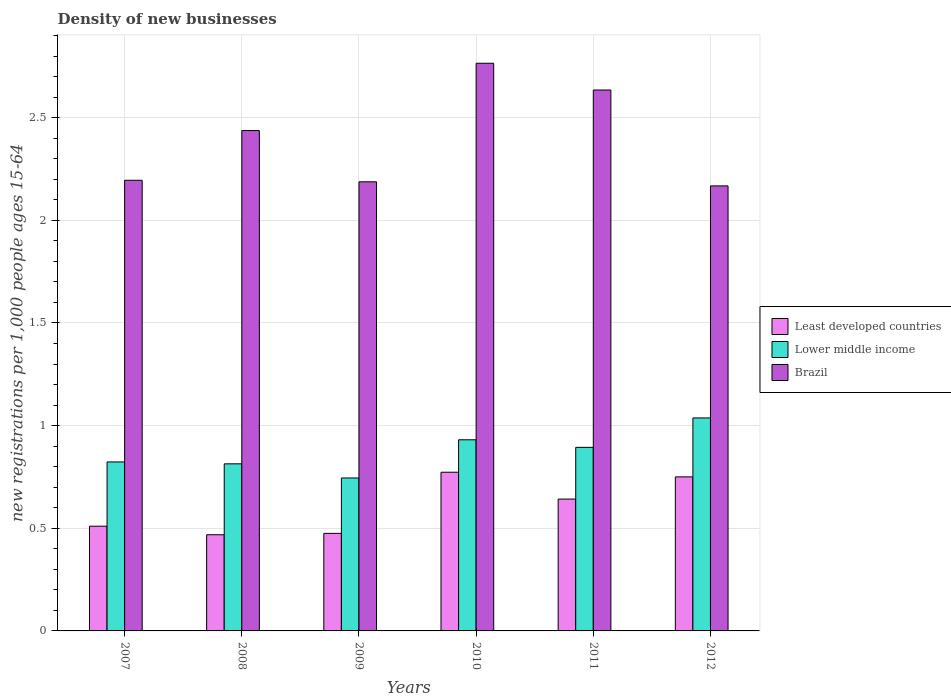In how many cases, is the number of bars for a given year not equal to the number of legend labels?
Make the answer very short. 0. What is the number of new registrations in Lower middle income in 2008?
Offer a terse response. 0.81. Across all years, what is the maximum number of new registrations in Least developed countries?
Make the answer very short. 0.77. Across all years, what is the minimum number of new registrations in Brazil?
Provide a succinct answer. 2.17. In which year was the number of new registrations in Lower middle income maximum?
Offer a terse response. 2012. In which year was the number of new registrations in Lower middle income minimum?
Make the answer very short. 2009. What is the total number of new registrations in Least developed countries in the graph?
Provide a short and direct response. 3.62. What is the difference between the number of new registrations in Lower middle income in 2008 and that in 2010?
Your answer should be compact. -0.12. What is the difference between the number of new registrations in Brazil in 2008 and the number of new registrations in Lower middle income in 2009?
Your answer should be compact. 1.69. What is the average number of new registrations in Brazil per year?
Give a very brief answer. 2.4. In the year 2008, what is the difference between the number of new registrations in Brazil and number of new registrations in Lower middle income?
Make the answer very short. 1.62. In how many years, is the number of new registrations in Least developed countries greater than 1?
Offer a terse response. 0. What is the ratio of the number of new registrations in Lower middle income in 2007 to that in 2008?
Your answer should be very brief. 1.01. Is the difference between the number of new registrations in Brazil in 2010 and 2012 greater than the difference between the number of new registrations in Lower middle income in 2010 and 2012?
Keep it short and to the point. Yes. What is the difference between the highest and the second highest number of new registrations in Lower middle income?
Ensure brevity in your answer.  0.11. What is the difference between the highest and the lowest number of new registrations in Brazil?
Keep it short and to the point. 0.6. What does the 1st bar from the right in 2009 represents?
Offer a terse response. Brazil. How many years are there in the graph?
Your answer should be very brief. 6. Are the values on the major ticks of Y-axis written in scientific E-notation?
Your answer should be very brief. No. Does the graph contain grids?
Your answer should be very brief. Yes. Where does the legend appear in the graph?
Offer a very short reply. Center right. What is the title of the graph?
Your answer should be compact. Density of new businesses. What is the label or title of the X-axis?
Provide a short and direct response. Years. What is the label or title of the Y-axis?
Ensure brevity in your answer.  New registrations per 1,0 people ages 15-64. What is the new registrations per 1,000 people ages 15-64 in Least developed countries in 2007?
Keep it short and to the point. 0.51. What is the new registrations per 1,000 people ages 15-64 of Lower middle income in 2007?
Keep it short and to the point. 0.82. What is the new registrations per 1,000 people ages 15-64 in Brazil in 2007?
Your answer should be very brief. 2.19. What is the new registrations per 1,000 people ages 15-64 in Least developed countries in 2008?
Make the answer very short. 0.47. What is the new registrations per 1,000 people ages 15-64 in Lower middle income in 2008?
Make the answer very short. 0.81. What is the new registrations per 1,000 people ages 15-64 of Brazil in 2008?
Offer a very short reply. 2.44. What is the new registrations per 1,000 people ages 15-64 in Least developed countries in 2009?
Your answer should be very brief. 0.48. What is the new registrations per 1,000 people ages 15-64 in Lower middle income in 2009?
Your answer should be very brief. 0.74. What is the new registrations per 1,000 people ages 15-64 of Brazil in 2009?
Provide a short and direct response. 2.19. What is the new registrations per 1,000 people ages 15-64 of Least developed countries in 2010?
Keep it short and to the point. 0.77. What is the new registrations per 1,000 people ages 15-64 of Lower middle income in 2010?
Your answer should be very brief. 0.93. What is the new registrations per 1,000 people ages 15-64 in Brazil in 2010?
Provide a short and direct response. 2.76. What is the new registrations per 1,000 people ages 15-64 in Least developed countries in 2011?
Your answer should be compact. 0.64. What is the new registrations per 1,000 people ages 15-64 in Lower middle income in 2011?
Ensure brevity in your answer.  0.89. What is the new registrations per 1,000 people ages 15-64 in Brazil in 2011?
Make the answer very short. 2.63. What is the new registrations per 1,000 people ages 15-64 of Least developed countries in 2012?
Offer a terse response. 0.75. What is the new registrations per 1,000 people ages 15-64 of Lower middle income in 2012?
Give a very brief answer. 1.04. What is the new registrations per 1,000 people ages 15-64 of Brazil in 2012?
Your answer should be very brief. 2.17. Across all years, what is the maximum new registrations per 1,000 people ages 15-64 of Least developed countries?
Provide a short and direct response. 0.77. Across all years, what is the maximum new registrations per 1,000 people ages 15-64 of Lower middle income?
Keep it short and to the point. 1.04. Across all years, what is the maximum new registrations per 1,000 people ages 15-64 in Brazil?
Give a very brief answer. 2.76. Across all years, what is the minimum new registrations per 1,000 people ages 15-64 of Least developed countries?
Ensure brevity in your answer.  0.47. Across all years, what is the minimum new registrations per 1,000 people ages 15-64 in Lower middle income?
Your answer should be very brief. 0.74. Across all years, what is the minimum new registrations per 1,000 people ages 15-64 in Brazil?
Your answer should be very brief. 2.17. What is the total new registrations per 1,000 people ages 15-64 of Least developed countries in the graph?
Your answer should be very brief. 3.62. What is the total new registrations per 1,000 people ages 15-64 of Lower middle income in the graph?
Make the answer very short. 5.24. What is the total new registrations per 1,000 people ages 15-64 of Brazil in the graph?
Make the answer very short. 14.39. What is the difference between the new registrations per 1,000 people ages 15-64 in Least developed countries in 2007 and that in 2008?
Give a very brief answer. 0.04. What is the difference between the new registrations per 1,000 people ages 15-64 of Lower middle income in 2007 and that in 2008?
Give a very brief answer. 0.01. What is the difference between the new registrations per 1,000 people ages 15-64 of Brazil in 2007 and that in 2008?
Offer a terse response. -0.24. What is the difference between the new registrations per 1,000 people ages 15-64 of Least developed countries in 2007 and that in 2009?
Offer a very short reply. 0.03. What is the difference between the new registrations per 1,000 people ages 15-64 in Lower middle income in 2007 and that in 2009?
Your answer should be very brief. 0.08. What is the difference between the new registrations per 1,000 people ages 15-64 of Brazil in 2007 and that in 2009?
Provide a succinct answer. 0.01. What is the difference between the new registrations per 1,000 people ages 15-64 of Least developed countries in 2007 and that in 2010?
Your answer should be very brief. -0.26. What is the difference between the new registrations per 1,000 people ages 15-64 of Lower middle income in 2007 and that in 2010?
Ensure brevity in your answer.  -0.11. What is the difference between the new registrations per 1,000 people ages 15-64 of Brazil in 2007 and that in 2010?
Make the answer very short. -0.57. What is the difference between the new registrations per 1,000 people ages 15-64 of Least developed countries in 2007 and that in 2011?
Make the answer very short. -0.13. What is the difference between the new registrations per 1,000 people ages 15-64 of Lower middle income in 2007 and that in 2011?
Keep it short and to the point. -0.07. What is the difference between the new registrations per 1,000 people ages 15-64 in Brazil in 2007 and that in 2011?
Keep it short and to the point. -0.44. What is the difference between the new registrations per 1,000 people ages 15-64 of Least developed countries in 2007 and that in 2012?
Your response must be concise. -0.24. What is the difference between the new registrations per 1,000 people ages 15-64 in Lower middle income in 2007 and that in 2012?
Make the answer very short. -0.21. What is the difference between the new registrations per 1,000 people ages 15-64 in Brazil in 2007 and that in 2012?
Your response must be concise. 0.03. What is the difference between the new registrations per 1,000 people ages 15-64 of Least developed countries in 2008 and that in 2009?
Offer a very short reply. -0.01. What is the difference between the new registrations per 1,000 people ages 15-64 of Lower middle income in 2008 and that in 2009?
Provide a short and direct response. 0.07. What is the difference between the new registrations per 1,000 people ages 15-64 of Brazil in 2008 and that in 2009?
Provide a short and direct response. 0.25. What is the difference between the new registrations per 1,000 people ages 15-64 in Least developed countries in 2008 and that in 2010?
Offer a terse response. -0.3. What is the difference between the new registrations per 1,000 people ages 15-64 of Lower middle income in 2008 and that in 2010?
Make the answer very short. -0.12. What is the difference between the new registrations per 1,000 people ages 15-64 in Brazil in 2008 and that in 2010?
Offer a very short reply. -0.33. What is the difference between the new registrations per 1,000 people ages 15-64 in Least developed countries in 2008 and that in 2011?
Your answer should be compact. -0.17. What is the difference between the new registrations per 1,000 people ages 15-64 of Lower middle income in 2008 and that in 2011?
Your answer should be compact. -0.08. What is the difference between the new registrations per 1,000 people ages 15-64 of Brazil in 2008 and that in 2011?
Make the answer very short. -0.2. What is the difference between the new registrations per 1,000 people ages 15-64 of Least developed countries in 2008 and that in 2012?
Offer a very short reply. -0.28. What is the difference between the new registrations per 1,000 people ages 15-64 of Lower middle income in 2008 and that in 2012?
Provide a short and direct response. -0.22. What is the difference between the new registrations per 1,000 people ages 15-64 in Brazil in 2008 and that in 2012?
Make the answer very short. 0.27. What is the difference between the new registrations per 1,000 people ages 15-64 in Least developed countries in 2009 and that in 2010?
Your answer should be compact. -0.3. What is the difference between the new registrations per 1,000 people ages 15-64 in Lower middle income in 2009 and that in 2010?
Offer a very short reply. -0.19. What is the difference between the new registrations per 1,000 people ages 15-64 of Brazil in 2009 and that in 2010?
Ensure brevity in your answer.  -0.58. What is the difference between the new registrations per 1,000 people ages 15-64 in Least developed countries in 2009 and that in 2011?
Provide a short and direct response. -0.17. What is the difference between the new registrations per 1,000 people ages 15-64 of Lower middle income in 2009 and that in 2011?
Provide a succinct answer. -0.15. What is the difference between the new registrations per 1,000 people ages 15-64 in Brazil in 2009 and that in 2011?
Make the answer very short. -0.45. What is the difference between the new registrations per 1,000 people ages 15-64 in Least developed countries in 2009 and that in 2012?
Your answer should be very brief. -0.28. What is the difference between the new registrations per 1,000 people ages 15-64 in Lower middle income in 2009 and that in 2012?
Offer a terse response. -0.29. What is the difference between the new registrations per 1,000 people ages 15-64 of Brazil in 2009 and that in 2012?
Offer a terse response. 0.02. What is the difference between the new registrations per 1,000 people ages 15-64 in Least developed countries in 2010 and that in 2011?
Give a very brief answer. 0.13. What is the difference between the new registrations per 1,000 people ages 15-64 in Lower middle income in 2010 and that in 2011?
Offer a terse response. 0.04. What is the difference between the new registrations per 1,000 people ages 15-64 in Brazil in 2010 and that in 2011?
Make the answer very short. 0.13. What is the difference between the new registrations per 1,000 people ages 15-64 of Least developed countries in 2010 and that in 2012?
Offer a terse response. 0.02. What is the difference between the new registrations per 1,000 people ages 15-64 in Lower middle income in 2010 and that in 2012?
Keep it short and to the point. -0.11. What is the difference between the new registrations per 1,000 people ages 15-64 in Brazil in 2010 and that in 2012?
Your response must be concise. 0.6. What is the difference between the new registrations per 1,000 people ages 15-64 in Least developed countries in 2011 and that in 2012?
Ensure brevity in your answer.  -0.11. What is the difference between the new registrations per 1,000 people ages 15-64 of Lower middle income in 2011 and that in 2012?
Your response must be concise. -0.14. What is the difference between the new registrations per 1,000 people ages 15-64 of Brazil in 2011 and that in 2012?
Offer a very short reply. 0.47. What is the difference between the new registrations per 1,000 people ages 15-64 of Least developed countries in 2007 and the new registrations per 1,000 people ages 15-64 of Lower middle income in 2008?
Your response must be concise. -0.3. What is the difference between the new registrations per 1,000 people ages 15-64 in Least developed countries in 2007 and the new registrations per 1,000 people ages 15-64 in Brazil in 2008?
Your answer should be compact. -1.93. What is the difference between the new registrations per 1,000 people ages 15-64 of Lower middle income in 2007 and the new registrations per 1,000 people ages 15-64 of Brazil in 2008?
Offer a very short reply. -1.61. What is the difference between the new registrations per 1,000 people ages 15-64 in Least developed countries in 2007 and the new registrations per 1,000 people ages 15-64 in Lower middle income in 2009?
Offer a terse response. -0.23. What is the difference between the new registrations per 1,000 people ages 15-64 of Least developed countries in 2007 and the new registrations per 1,000 people ages 15-64 of Brazil in 2009?
Your answer should be very brief. -1.68. What is the difference between the new registrations per 1,000 people ages 15-64 of Lower middle income in 2007 and the new registrations per 1,000 people ages 15-64 of Brazil in 2009?
Provide a short and direct response. -1.36. What is the difference between the new registrations per 1,000 people ages 15-64 in Least developed countries in 2007 and the new registrations per 1,000 people ages 15-64 in Lower middle income in 2010?
Your answer should be compact. -0.42. What is the difference between the new registrations per 1,000 people ages 15-64 in Least developed countries in 2007 and the new registrations per 1,000 people ages 15-64 in Brazil in 2010?
Provide a succinct answer. -2.25. What is the difference between the new registrations per 1,000 people ages 15-64 in Lower middle income in 2007 and the new registrations per 1,000 people ages 15-64 in Brazil in 2010?
Provide a succinct answer. -1.94. What is the difference between the new registrations per 1,000 people ages 15-64 of Least developed countries in 2007 and the new registrations per 1,000 people ages 15-64 of Lower middle income in 2011?
Offer a very short reply. -0.38. What is the difference between the new registrations per 1,000 people ages 15-64 of Least developed countries in 2007 and the new registrations per 1,000 people ages 15-64 of Brazil in 2011?
Your response must be concise. -2.12. What is the difference between the new registrations per 1,000 people ages 15-64 in Lower middle income in 2007 and the new registrations per 1,000 people ages 15-64 in Brazil in 2011?
Your response must be concise. -1.81. What is the difference between the new registrations per 1,000 people ages 15-64 in Least developed countries in 2007 and the new registrations per 1,000 people ages 15-64 in Lower middle income in 2012?
Your answer should be very brief. -0.53. What is the difference between the new registrations per 1,000 people ages 15-64 in Least developed countries in 2007 and the new registrations per 1,000 people ages 15-64 in Brazil in 2012?
Your response must be concise. -1.66. What is the difference between the new registrations per 1,000 people ages 15-64 in Lower middle income in 2007 and the new registrations per 1,000 people ages 15-64 in Brazil in 2012?
Your answer should be compact. -1.34. What is the difference between the new registrations per 1,000 people ages 15-64 of Least developed countries in 2008 and the new registrations per 1,000 people ages 15-64 of Lower middle income in 2009?
Give a very brief answer. -0.28. What is the difference between the new registrations per 1,000 people ages 15-64 in Least developed countries in 2008 and the new registrations per 1,000 people ages 15-64 in Brazil in 2009?
Make the answer very short. -1.72. What is the difference between the new registrations per 1,000 people ages 15-64 in Lower middle income in 2008 and the new registrations per 1,000 people ages 15-64 in Brazil in 2009?
Ensure brevity in your answer.  -1.37. What is the difference between the new registrations per 1,000 people ages 15-64 in Least developed countries in 2008 and the new registrations per 1,000 people ages 15-64 in Lower middle income in 2010?
Make the answer very short. -0.46. What is the difference between the new registrations per 1,000 people ages 15-64 in Least developed countries in 2008 and the new registrations per 1,000 people ages 15-64 in Brazil in 2010?
Ensure brevity in your answer.  -2.3. What is the difference between the new registrations per 1,000 people ages 15-64 in Lower middle income in 2008 and the new registrations per 1,000 people ages 15-64 in Brazil in 2010?
Make the answer very short. -1.95. What is the difference between the new registrations per 1,000 people ages 15-64 of Least developed countries in 2008 and the new registrations per 1,000 people ages 15-64 of Lower middle income in 2011?
Provide a short and direct response. -0.43. What is the difference between the new registrations per 1,000 people ages 15-64 in Least developed countries in 2008 and the new registrations per 1,000 people ages 15-64 in Brazil in 2011?
Your response must be concise. -2.17. What is the difference between the new registrations per 1,000 people ages 15-64 in Lower middle income in 2008 and the new registrations per 1,000 people ages 15-64 in Brazil in 2011?
Your answer should be compact. -1.82. What is the difference between the new registrations per 1,000 people ages 15-64 of Least developed countries in 2008 and the new registrations per 1,000 people ages 15-64 of Lower middle income in 2012?
Keep it short and to the point. -0.57. What is the difference between the new registrations per 1,000 people ages 15-64 of Least developed countries in 2008 and the new registrations per 1,000 people ages 15-64 of Brazil in 2012?
Provide a succinct answer. -1.7. What is the difference between the new registrations per 1,000 people ages 15-64 in Lower middle income in 2008 and the new registrations per 1,000 people ages 15-64 in Brazil in 2012?
Provide a short and direct response. -1.35. What is the difference between the new registrations per 1,000 people ages 15-64 of Least developed countries in 2009 and the new registrations per 1,000 people ages 15-64 of Lower middle income in 2010?
Offer a terse response. -0.46. What is the difference between the new registrations per 1,000 people ages 15-64 of Least developed countries in 2009 and the new registrations per 1,000 people ages 15-64 of Brazil in 2010?
Provide a short and direct response. -2.29. What is the difference between the new registrations per 1,000 people ages 15-64 of Lower middle income in 2009 and the new registrations per 1,000 people ages 15-64 of Brazil in 2010?
Make the answer very short. -2.02. What is the difference between the new registrations per 1,000 people ages 15-64 in Least developed countries in 2009 and the new registrations per 1,000 people ages 15-64 in Lower middle income in 2011?
Ensure brevity in your answer.  -0.42. What is the difference between the new registrations per 1,000 people ages 15-64 in Least developed countries in 2009 and the new registrations per 1,000 people ages 15-64 in Brazil in 2011?
Your answer should be very brief. -2.16. What is the difference between the new registrations per 1,000 people ages 15-64 in Lower middle income in 2009 and the new registrations per 1,000 people ages 15-64 in Brazil in 2011?
Your answer should be very brief. -1.89. What is the difference between the new registrations per 1,000 people ages 15-64 of Least developed countries in 2009 and the new registrations per 1,000 people ages 15-64 of Lower middle income in 2012?
Make the answer very short. -0.56. What is the difference between the new registrations per 1,000 people ages 15-64 of Least developed countries in 2009 and the new registrations per 1,000 people ages 15-64 of Brazil in 2012?
Ensure brevity in your answer.  -1.69. What is the difference between the new registrations per 1,000 people ages 15-64 in Lower middle income in 2009 and the new registrations per 1,000 people ages 15-64 in Brazil in 2012?
Keep it short and to the point. -1.42. What is the difference between the new registrations per 1,000 people ages 15-64 of Least developed countries in 2010 and the new registrations per 1,000 people ages 15-64 of Lower middle income in 2011?
Provide a short and direct response. -0.12. What is the difference between the new registrations per 1,000 people ages 15-64 of Least developed countries in 2010 and the new registrations per 1,000 people ages 15-64 of Brazil in 2011?
Give a very brief answer. -1.86. What is the difference between the new registrations per 1,000 people ages 15-64 in Lower middle income in 2010 and the new registrations per 1,000 people ages 15-64 in Brazil in 2011?
Ensure brevity in your answer.  -1.7. What is the difference between the new registrations per 1,000 people ages 15-64 of Least developed countries in 2010 and the new registrations per 1,000 people ages 15-64 of Lower middle income in 2012?
Make the answer very short. -0.26. What is the difference between the new registrations per 1,000 people ages 15-64 in Least developed countries in 2010 and the new registrations per 1,000 people ages 15-64 in Brazil in 2012?
Provide a short and direct response. -1.39. What is the difference between the new registrations per 1,000 people ages 15-64 in Lower middle income in 2010 and the new registrations per 1,000 people ages 15-64 in Brazil in 2012?
Provide a succinct answer. -1.24. What is the difference between the new registrations per 1,000 people ages 15-64 in Least developed countries in 2011 and the new registrations per 1,000 people ages 15-64 in Lower middle income in 2012?
Provide a succinct answer. -0.4. What is the difference between the new registrations per 1,000 people ages 15-64 of Least developed countries in 2011 and the new registrations per 1,000 people ages 15-64 of Brazil in 2012?
Your response must be concise. -1.53. What is the difference between the new registrations per 1,000 people ages 15-64 in Lower middle income in 2011 and the new registrations per 1,000 people ages 15-64 in Brazil in 2012?
Keep it short and to the point. -1.27. What is the average new registrations per 1,000 people ages 15-64 of Least developed countries per year?
Offer a very short reply. 0.6. What is the average new registrations per 1,000 people ages 15-64 of Lower middle income per year?
Offer a very short reply. 0.87. What is the average new registrations per 1,000 people ages 15-64 in Brazil per year?
Your response must be concise. 2.4. In the year 2007, what is the difference between the new registrations per 1,000 people ages 15-64 in Least developed countries and new registrations per 1,000 people ages 15-64 in Lower middle income?
Keep it short and to the point. -0.31. In the year 2007, what is the difference between the new registrations per 1,000 people ages 15-64 in Least developed countries and new registrations per 1,000 people ages 15-64 in Brazil?
Keep it short and to the point. -1.68. In the year 2007, what is the difference between the new registrations per 1,000 people ages 15-64 of Lower middle income and new registrations per 1,000 people ages 15-64 of Brazil?
Ensure brevity in your answer.  -1.37. In the year 2008, what is the difference between the new registrations per 1,000 people ages 15-64 in Least developed countries and new registrations per 1,000 people ages 15-64 in Lower middle income?
Ensure brevity in your answer.  -0.35. In the year 2008, what is the difference between the new registrations per 1,000 people ages 15-64 in Least developed countries and new registrations per 1,000 people ages 15-64 in Brazil?
Offer a terse response. -1.97. In the year 2008, what is the difference between the new registrations per 1,000 people ages 15-64 in Lower middle income and new registrations per 1,000 people ages 15-64 in Brazil?
Ensure brevity in your answer.  -1.62. In the year 2009, what is the difference between the new registrations per 1,000 people ages 15-64 in Least developed countries and new registrations per 1,000 people ages 15-64 in Lower middle income?
Make the answer very short. -0.27. In the year 2009, what is the difference between the new registrations per 1,000 people ages 15-64 of Least developed countries and new registrations per 1,000 people ages 15-64 of Brazil?
Offer a very short reply. -1.71. In the year 2009, what is the difference between the new registrations per 1,000 people ages 15-64 of Lower middle income and new registrations per 1,000 people ages 15-64 of Brazil?
Give a very brief answer. -1.44. In the year 2010, what is the difference between the new registrations per 1,000 people ages 15-64 in Least developed countries and new registrations per 1,000 people ages 15-64 in Lower middle income?
Your answer should be very brief. -0.16. In the year 2010, what is the difference between the new registrations per 1,000 people ages 15-64 of Least developed countries and new registrations per 1,000 people ages 15-64 of Brazil?
Offer a very short reply. -1.99. In the year 2010, what is the difference between the new registrations per 1,000 people ages 15-64 in Lower middle income and new registrations per 1,000 people ages 15-64 in Brazil?
Ensure brevity in your answer.  -1.83. In the year 2011, what is the difference between the new registrations per 1,000 people ages 15-64 in Least developed countries and new registrations per 1,000 people ages 15-64 in Lower middle income?
Offer a very short reply. -0.25. In the year 2011, what is the difference between the new registrations per 1,000 people ages 15-64 in Least developed countries and new registrations per 1,000 people ages 15-64 in Brazil?
Offer a very short reply. -1.99. In the year 2011, what is the difference between the new registrations per 1,000 people ages 15-64 of Lower middle income and new registrations per 1,000 people ages 15-64 of Brazil?
Offer a terse response. -1.74. In the year 2012, what is the difference between the new registrations per 1,000 people ages 15-64 in Least developed countries and new registrations per 1,000 people ages 15-64 in Lower middle income?
Ensure brevity in your answer.  -0.29. In the year 2012, what is the difference between the new registrations per 1,000 people ages 15-64 of Least developed countries and new registrations per 1,000 people ages 15-64 of Brazil?
Offer a terse response. -1.42. In the year 2012, what is the difference between the new registrations per 1,000 people ages 15-64 of Lower middle income and new registrations per 1,000 people ages 15-64 of Brazil?
Offer a terse response. -1.13. What is the ratio of the new registrations per 1,000 people ages 15-64 of Least developed countries in 2007 to that in 2008?
Provide a short and direct response. 1.09. What is the ratio of the new registrations per 1,000 people ages 15-64 in Lower middle income in 2007 to that in 2008?
Offer a very short reply. 1.01. What is the ratio of the new registrations per 1,000 people ages 15-64 in Brazil in 2007 to that in 2008?
Offer a very short reply. 0.9. What is the ratio of the new registrations per 1,000 people ages 15-64 in Least developed countries in 2007 to that in 2009?
Offer a very short reply. 1.07. What is the ratio of the new registrations per 1,000 people ages 15-64 in Lower middle income in 2007 to that in 2009?
Offer a very short reply. 1.1. What is the ratio of the new registrations per 1,000 people ages 15-64 of Least developed countries in 2007 to that in 2010?
Give a very brief answer. 0.66. What is the ratio of the new registrations per 1,000 people ages 15-64 of Lower middle income in 2007 to that in 2010?
Offer a terse response. 0.88. What is the ratio of the new registrations per 1,000 people ages 15-64 of Brazil in 2007 to that in 2010?
Provide a succinct answer. 0.79. What is the ratio of the new registrations per 1,000 people ages 15-64 of Least developed countries in 2007 to that in 2011?
Ensure brevity in your answer.  0.79. What is the ratio of the new registrations per 1,000 people ages 15-64 in Lower middle income in 2007 to that in 2011?
Your answer should be compact. 0.92. What is the ratio of the new registrations per 1,000 people ages 15-64 of Brazil in 2007 to that in 2011?
Provide a short and direct response. 0.83. What is the ratio of the new registrations per 1,000 people ages 15-64 in Least developed countries in 2007 to that in 2012?
Your answer should be compact. 0.68. What is the ratio of the new registrations per 1,000 people ages 15-64 of Lower middle income in 2007 to that in 2012?
Your answer should be compact. 0.79. What is the ratio of the new registrations per 1,000 people ages 15-64 of Brazil in 2007 to that in 2012?
Offer a very short reply. 1.01. What is the ratio of the new registrations per 1,000 people ages 15-64 in Least developed countries in 2008 to that in 2009?
Keep it short and to the point. 0.99. What is the ratio of the new registrations per 1,000 people ages 15-64 of Lower middle income in 2008 to that in 2009?
Offer a very short reply. 1.09. What is the ratio of the new registrations per 1,000 people ages 15-64 of Brazil in 2008 to that in 2009?
Offer a terse response. 1.11. What is the ratio of the new registrations per 1,000 people ages 15-64 of Least developed countries in 2008 to that in 2010?
Your answer should be compact. 0.61. What is the ratio of the new registrations per 1,000 people ages 15-64 in Lower middle income in 2008 to that in 2010?
Give a very brief answer. 0.87. What is the ratio of the new registrations per 1,000 people ages 15-64 in Brazil in 2008 to that in 2010?
Keep it short and to the point. 0.88. What is the ratio of the new registrations per 1,000 people ages 15-64 of Least developed countries in 2008 to that in 2011?
Ensure brevity in your answer.  0.73. What is the ratio of the new registrations per 1,000 people ages 15-64 in Lower middle income in 2008 to that in 2011?
Offer a terse response. 0.91. What is the ratio of the new registrations per 1,000 people ages 15-64 of Brazil in 2008 to that in 2011?
Your answer should be compact. 0.93. What is the ratio of the new registrations per 1,000 people ages 15-64 of Least developed countries in 2008 to that in 2012?
Offer a terse response. 0.62. What is the ratio of the new registrations per 1,000 people ages 15-64 in Lower middle income in 2008 to that in 2012?
Give a very brief answer. 0.78. What is the ratio of the new registrations per 1,000 people ages 15-64 of Brazil in 2008 to that in 2012?
Your answer should be compact. 1.12. What is the ratio of the new registrations per 1,000 people ages 15-64 of Least developed countries in 2009 to that in 2010?
Provide a short and direct response. 0.61. What is the ratio of the new registrations per 1,000 people ages 15-64 in Lower middle income in 2009 to that in 2010?
Provide a succinct answer. 0.8. What is the ratio of the new registrations per 1,000 people ages 15-64 of Brazil in 2009 to that in 2010?
Your answer should be very brief. 0.79. What is the ratio of the new registrations per 1,000 people ages 15-64 of Least developed countries in 2009 to that in 2011?
Ensure brevity in your answer.  0.74. What is the ratio of the new registrations per 1,000 people ages 15-64 of Lower middle income in 2009 to that in 2011?
Provide a succinct answer. 0.83. What is the ratio of the new registrations per 1,000 people ages 15-64 of Brazil in 2009 to that in 2011?
Provide a short and direct response. 0.83. What is the ratio of the new registrations per 1,000 people ages 15-64 in Least developed countries in 2009 to that in 2012?
Your answer should be very brief. 0.63. What is the ratio of the new registrations per 1,000 people ages 15-64 of Lower middle income in 2009 to that in 2012?
Offer a terse response. 0.72. What is the ratio of the new registrations per 1,000 people ages 15-64 of Brazil in 2009 to that in 2012?
Ensure brevity in your answer.  1.01. What is the ratio of the new registrations per 1,000 people ages 15-64 of Least developed countries in 2010 to that in 2011?
Provide a succinct answer. 1.2. What is the ratio of the new registrations per 1,000 people ages 15-64 in Lower middle income in 2010 to that in 2011?
Offer a terse response. 1.04. What is the ratio of the new registrations per 1,000 people ages 15-64 in Brazil in 2010 to that in 2011?
Keep it short and to the point. 1.05. What is the ratio of the new registrations per 1,000 people ages 15-64 of Least developed countries in 2010 to that in 2012?
Keep it short and to the point. 1.03. What is the ratio of the new registrations per 1,000 people ages 15-64 of Lower middle income in 2010 to that in 2012?
Provide a succinct answer. 0.9. What is the ratio of the new registrations per 1,000 people ages 15-64 in Brazil in 2010 to that in 2012?
Your response must be concise. 1.28. What is the ratio of the new registrations per 1,000 people ages 15-64 of Least developed countries in 2011 to that in 2012?
Make the answer very short. 0.86. What is the ratio of the new registrations per 1,000 people ages 15-64 of Lower middle income in 2011 to that in 2012?
Provide a short and direct response. 0.86. What is the ratio of the new registrations per 1,000 people ages 15-64 in Brazil in 2011 to that in 2012?
Provide a succinct answer. 1.22. What is the difference between the highest and the second highest new registrations per 1,000 people ages 15-64 of Least developed countries?
Your answer should be very brief. 0.02. What is the difference between the highest and the second highest new registrations per 1,000 people ages 15-64 of Lower middle income?
Provide a succinct answer. 0.11. What is the difference between the highest and the second highest new registrations per 1,000 people ages 15-64 in Brazil?
Your answer should be compact. 0.13. What is the difference between the highest and the lowest new registrations per 1,000 people ages 15-64 of Least developed countries?
Your response must be concise. 0.3. What is the difference between the highest and the lowest new registrations per 1,000 people ages 15-64 of Lower middle income?
Offer a very short reply. 0.29. What is the difference between the highest and the lowest new registrations per 1,000 people ages 15-64 of Brazil?
Keep it short and to the point. 0.6. 